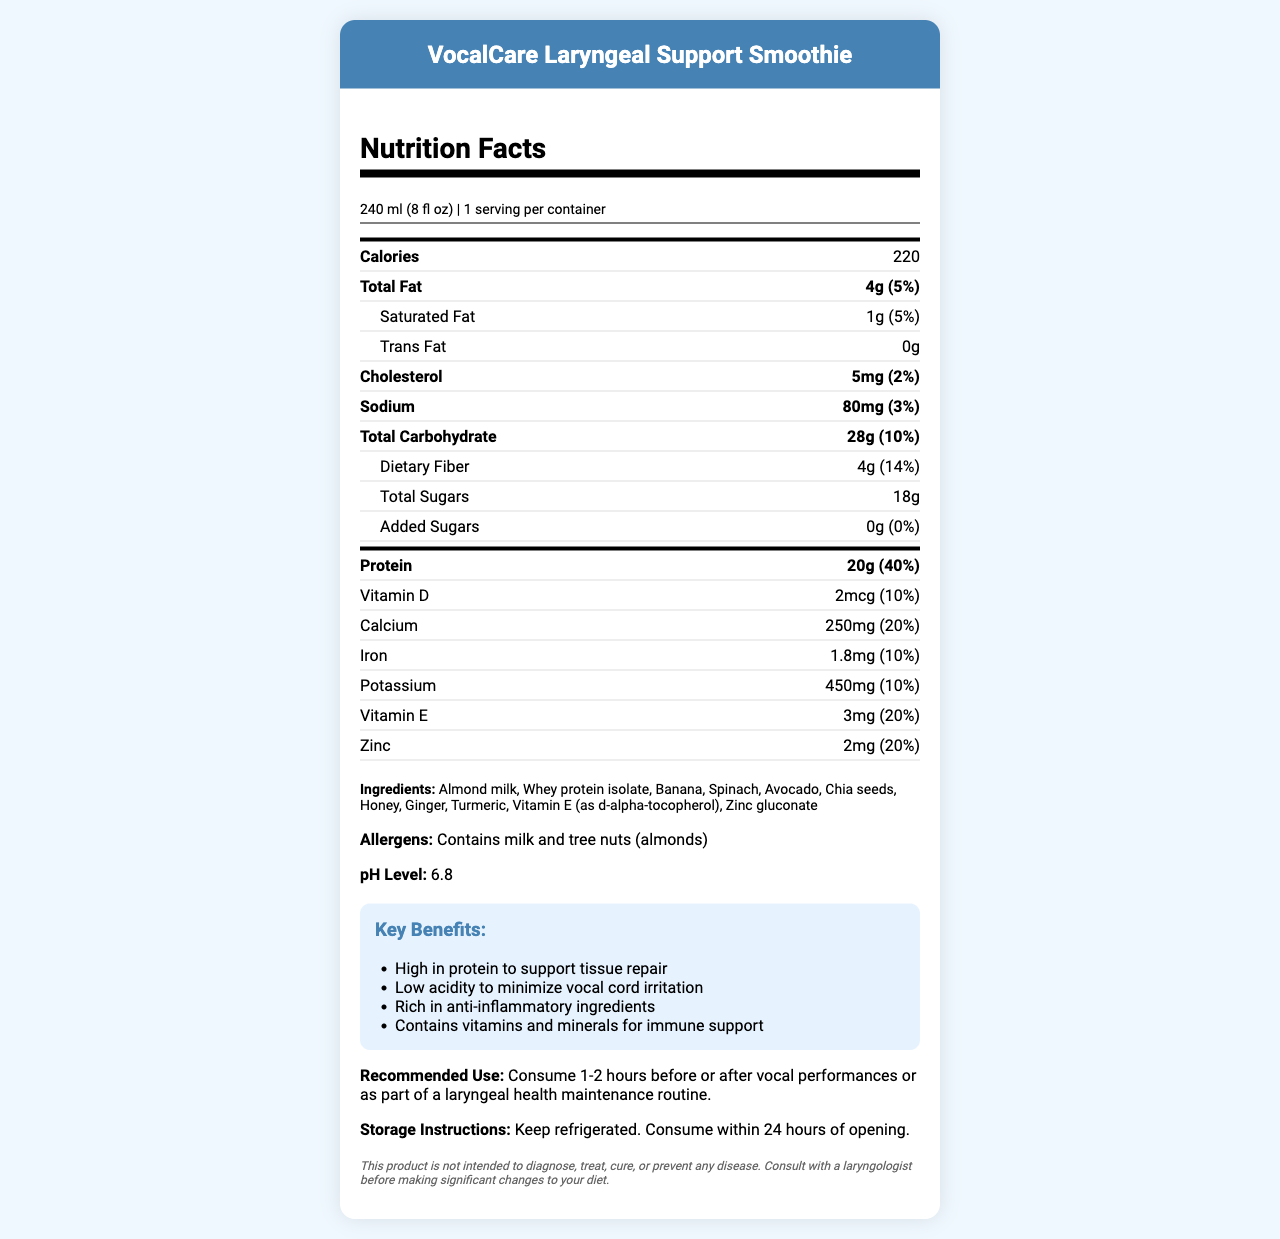what is the product name? The product name is clearly stated at the top of the document under the header section.
Answer: VocalCare Laryngeal Support Smoothie how many calories are in a serving? The calories per serving are listed at the top of the nutrition facts section.
Answer: 220 what is the protein content per serving? The protein content per serving is listed in the bold-line section for main nutrients.
Answer: 20g how much dietary fiber does each serving provide? The dietary fiber content is listed under the total carbohydrate section in the nutrition facts.
Answer: 4g what is the pH level of this smoothie? The pH level is listed near the end of the document in a specific section for pH Level.
Answer: 6.8 which ingredient contributes to antioxidants? A. Ginger B. Honey C. Chia seeds D. Spinach Spinach is known for its rich antioxidant content compared to the other options.
Answer: D. Spinach what is the primary benefit of this product? A. High in Protein B. Low in Sugars C. High in Fat The key benefits list the first point as being high in protein to support tissue repair.
Answer: A. High in Protein does this product contain any added sugars? The added sugars are listed as 0g in the nutrition facts.
Answer: No can this product diagnose or treat any disease? The disclaimer clearly states this product is not intended to diagnose, treat, cure, or prevent any disease.
Answer: No can you consume this product more than 24 hours after opening? The storage instructions indicate consuming within 24 hours of opening.
Answer: No describe the main purpose of this document. The document is a comprehensive overview of the VocalCare Laryngeal Support Smoothie, detailing its nutritional content, ingredients, key health benefits, recommended use, and storage guidelines.
Answer: The document provides detailed nutritional information, ingredients, allergens, benefits, and usage instructions for the VocalCare Laryngeal Support Smoothie aimed at supporting laryngeal health, especially for vocalists. what is the manufacturing date of this product? There is no information provided about the manufacturing date in the visual content of the document.
Answer: Cannot be determined 